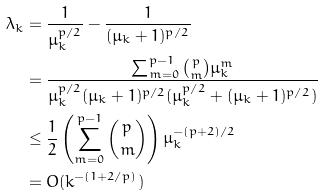Convert formula to latex. <formula><loc_0><loc_0><loc_500><loc_500>\lambda _ { k } & = \frac { 1 } { \mu _ { k } ^ { p / 2 } } - \frac { 1 } { ( \mu _ { k } + 1 ) ^ { p / 2 } } \\ & = \frac { \sum _ { m = 0 } ^ { p - 1 } \binom { p } { m } \mu _ { k } ^ { m } } { \mu _ { k } ^ { p / 2 } ( \mu _ { k } + 1 ) ^ { p / 2 } ( \mu _ { k } ^ { p / 2 } + ( \mu _ { k } + 1 ) ^ { p / 2 } ) } \\ & \leq \frac { 1 } { 2 } \left ( \sum _ { m = 0 } ^ { p - 1 } \binom { p } { m } \right ) \mu _ { k } ^ { - ( p + 2 ) / 2 } \\ & = O ( k ^ { - ( 1 + 2 / p ) } )</formula> 